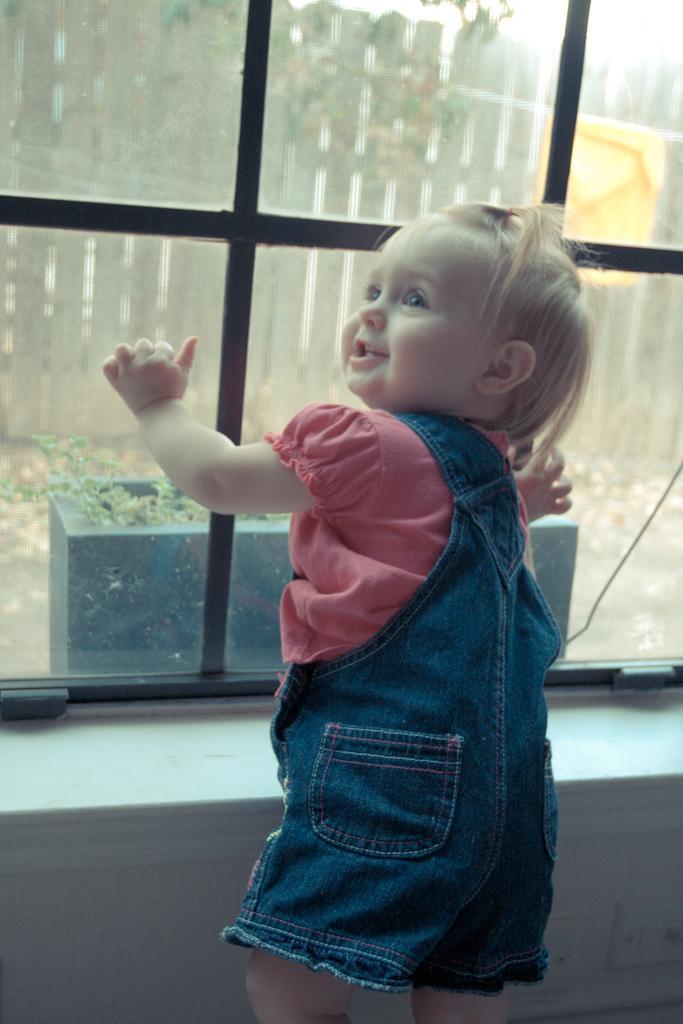Please provide a concise description of this image. In this picture i can see the cute baby girl who is standing near to the window and she is smiling. She is wearing pink and blue dress. Through the window i can see the plants, grass and many trees. At the top there is a sky. 